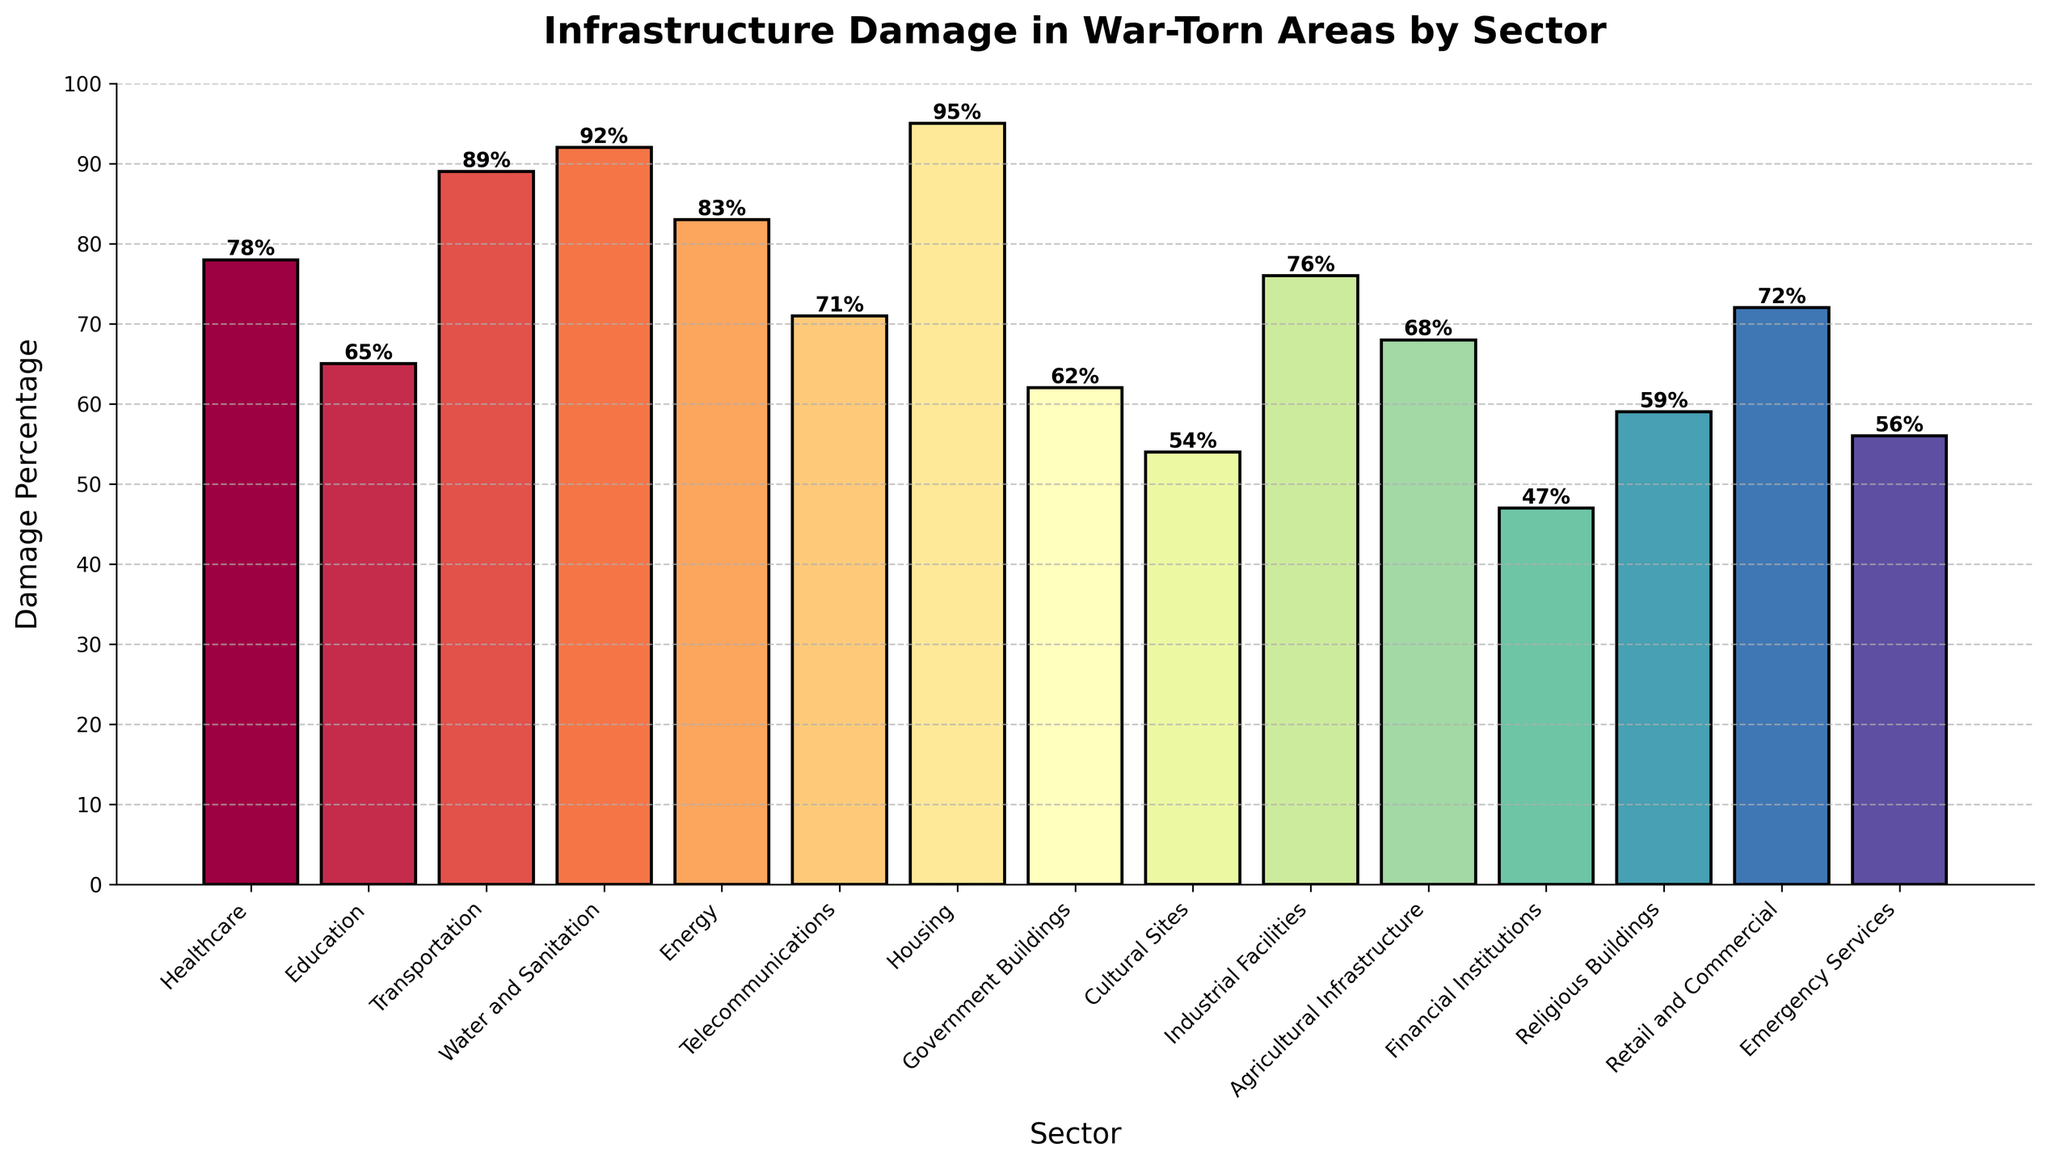Which sector experienced the highest percentage of infrastructure damage? The figure shows damage percentages for various sectors. By comparing the heights of the bars, the Housing sector has the highest bar with a damage percentage of 95%.
Answer: Housing Which sector experienced the lowest percentage of infrastructure damage? By examining the figure, the bar for Financial Institutions is the shortest, indicating it has the lowest damage percentage at 47%.
Answer: Financial Institutions By how much does the damage percentage in the Transportation sector exceed that in the Education sector? For Transportation, the damage percentage is 89%, and for Education, it is 65%. The difference is 89% - 65% = 24%.
Answer: 24% What is the average damage percentage across all sectors? Sum the damage percentages: 78 + 65 + 89 + 92 + 83 + 71 + 95 + 62 + 54 + 76 + 68 + 47 + 59 + 72 + 56 = 1067. There are 15 sectors, so the average is 1067 / 15.
Answer: 71.13 What is the median damage percentage? Arrange the damage percentages in ascending order: 47, 54, 56, 59, 62, 65, 68, 71, 72, 76, 78, 83, 89, 92, 95. The median is the middle value when the numbers are sorted, which in this case is the 8th value: 71.
Answer: 71 Which sector has a damage percentage closest to the average damage percentage? The average damage percentage is 71.13%. Comparing each sector's damage percentage to this average, the damage percentage for Telecommunications is exactly 71%, which is closest to the average.
Answer: Telecommunications Which sectors have damage percentages greater than 80%? By observing the figure, sectors with damage percentages over 80% are Healthcare (78%), Transportation (89%), Water and Sanitation (92%), Energy (83%), and Housing (95%).
Answer: Transportation, Water and Sanitation, Energy, Housing Is the damage percentage in the Religious Buildings sector more or less than the Cultural Sites sector? The damage percentage for Religious Buildings is 59%, and for Cultural Sites it is 54%. Since 59% > 54%, the damage is more in Religious Buildings.
Answer: More How much higher is the damage in Water and Sanitation compared to Emergency Services? Water and Sanitation has a damage percentage of 92%, and Emergency Services has 56%. The difference is 92% - 56% = 36%.
Answer: 36% Is the bar representing the Energy sector taller than the one for the Healthcare sector? Comparing the heights of the bars visually, Energy has a damage percentage of 83% and Healthcare has 78%. Since 83% > 78%, the Energy bar is taller.
Answer: Yes 